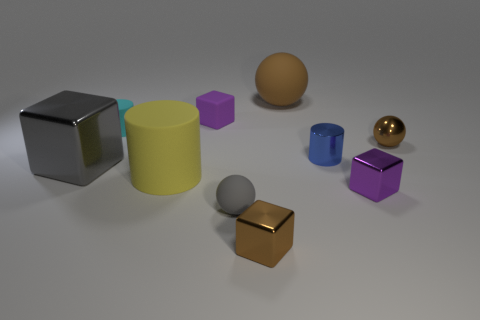Is the size of the yellow thing the same as the blue metallic cylinder?
Offer a very short reply. No. How many other things are there of the same shape as the yellow object?
Offer a terse response. 2. What material is the tiny sphere in front of the big matte cylinder in front of the tiny blue cylinder?
Offer a terse response. Rubber. There is a small cyan cylinder; are there any small blue metallic cylinders on the left side of it?
Offer a very short reply. No. There is a purple metal block; does it have the same size as the rubber ball that is behind the purple metallic cube?
Make the answer very short. No. There is a cyan object that is the same shape as the blue thing; what size is it?
Your response must be concise. Small. Do the metallic block that is behind the tiny purple shiny thing and the thing that is in front of the gray sphere have the same size?
Ensure brevity in your answer.  No. What number of small things are either gray metallic cubes or green metal cubes?
Provide a short and direct response. 0. How many things are to the left of the tiny purple rubber object and right of the gray metal block?
Make the answer very short. 2. Do the blue cylinder and the gray object on the right side of the big rubber cylinder have the same material?
Make the answer very short. No. 